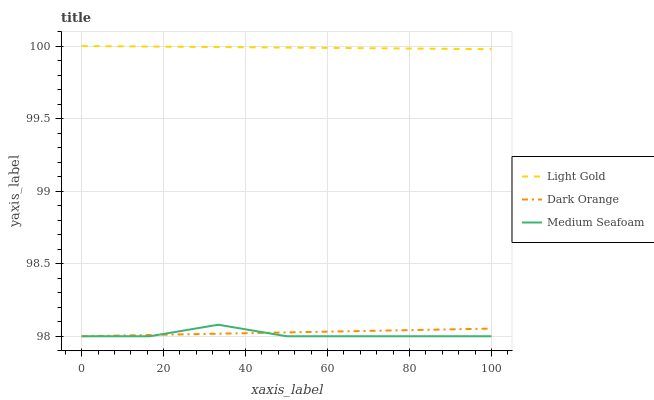Does Medium Seafoam have the minimum area under the curve?
Answer yes or no. Yes. Does Light Gold have the maximum area under the curve?
Answer yes or no. Yes. Does Light Gold have the minimum area under the curve?
Answer yes or no. No. Does Medium Seafoam have the maximum area under the curve?
Answer yes or no. No. Is Light Gold the smoothest?
Answer yes or no. Yes. Is Medium Seafoam the roughest?
Answer yes or no. Yes. Is Medium Seafoam the smoothest?
Answer yes or no. No. Is Light Gold the roughest?
Answer yes or no. No. Does Dark Orange have the lowest value?
Answer yes or no. Yes. Does Light Gold have the lowest value?
Answer yes or no. No. Does Light Gold have the highest value?
Answer yes or no. Yes. Does Medium Seafoam have the highest value?
Answer yes or no. No. Is Medium Seafoam less than Light Gold?
Answer yes or no. Yes. Is Light Gold greater than Dark Orange?
Answer yes or no. Yes. Does Medium Seafoam intersect Dark Orange?
Answer yes or no. Yes. Is Medium Seafoam less than Dark Orange?
Answer yes or no. No. Is Medium Seafoam greater than Dark Orange?
Answer yes or no. No. Does Medium Seafoam intersect Light Gold?
Answer yes or no. No. 